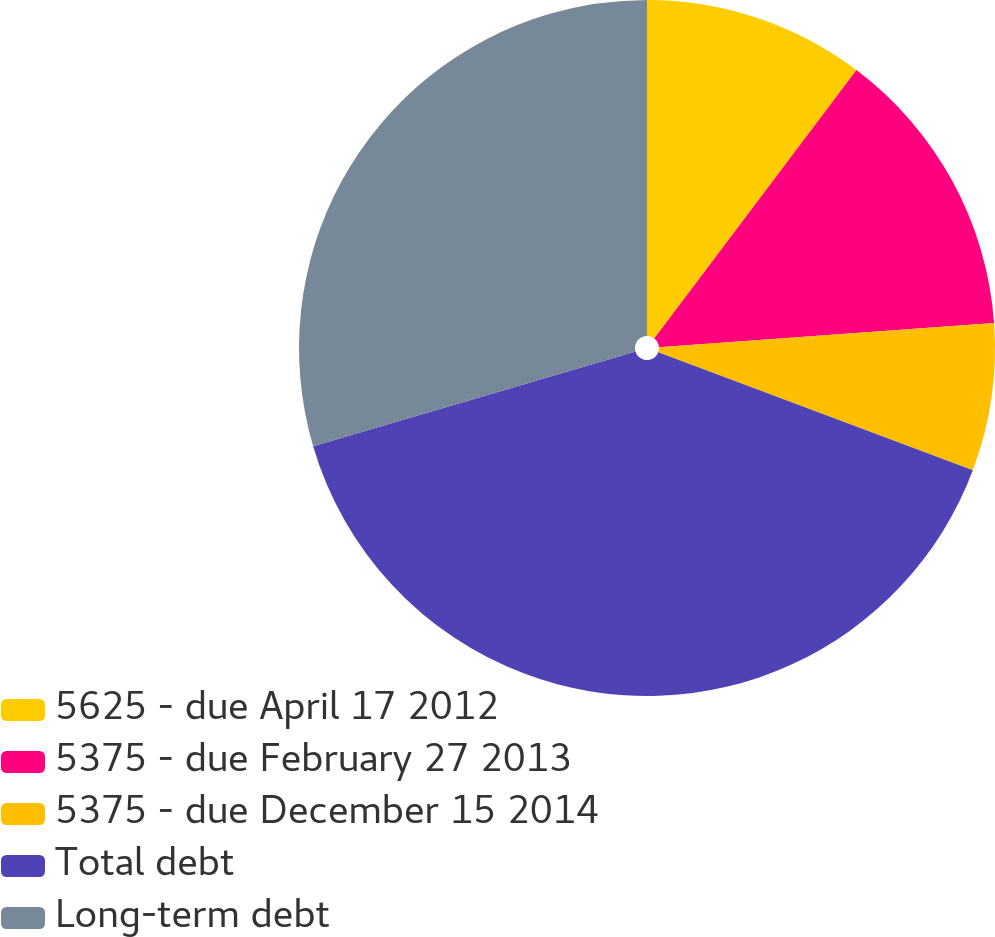<chart> <loc_0><loc_0><loc_500><loc_500><pie_chart><fcel>5625 - due April 17 2012<fcel>5375 - due February 27 2013<fcel>5375 - due December 15 2014<fcel>Total debt<fcel>Long-term debt<nl><fcel>10.28%<fcel>13.57%<fcel>6.86%<fcel>39.74%<fcel>29.55%<nl></chart> 